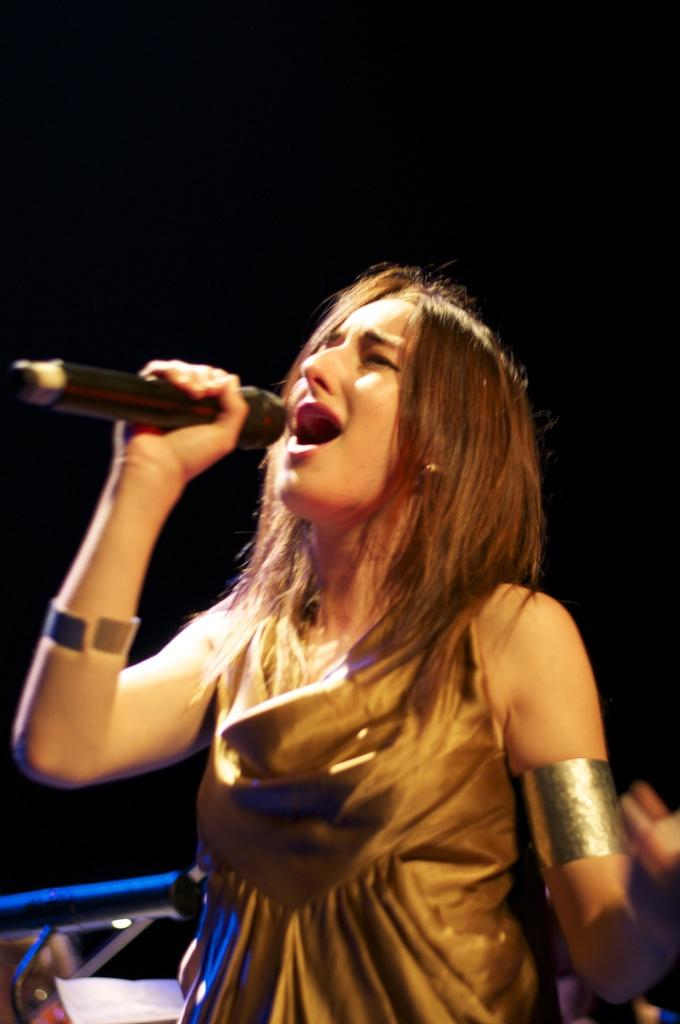Who is the main subject in the image? There is a woman in the image. What is the woman doing in the image? The woman is singing. What object is the woman holding in the image? The woman is holding a microphone. What is the woman wearing in the image? The woman is wearing a golden-colored dress. How much does the honey weigh in the image? There is no honey present in the image, so it is not possible to determine its weight. 